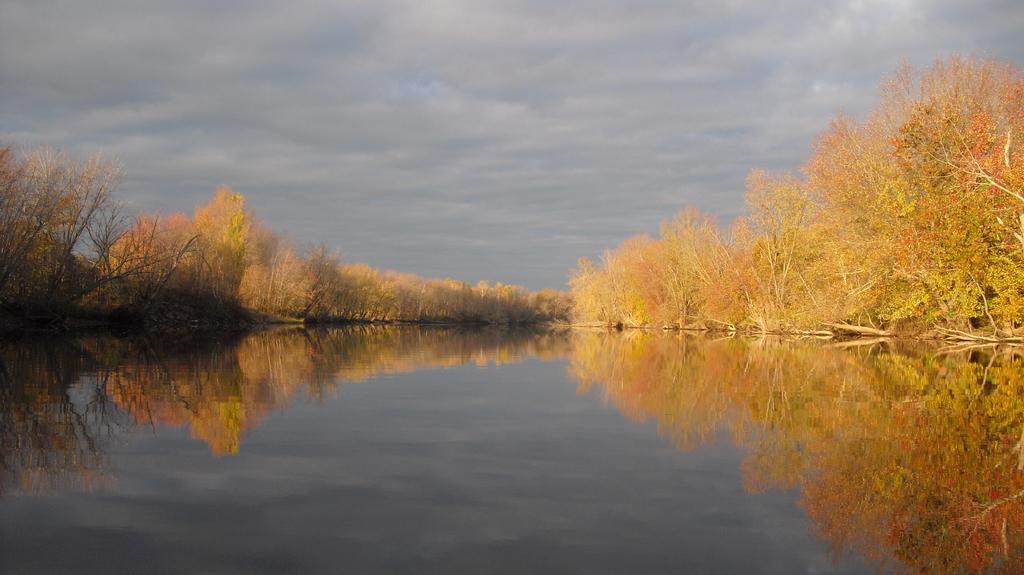Could you give a brief overview of what you see in this image? This picture is clicked outside the city. In the foreground there is a water body and we can see the reflection of the trees in the water body. In the background there is a sky which is full of clouds and we can see the trees. 